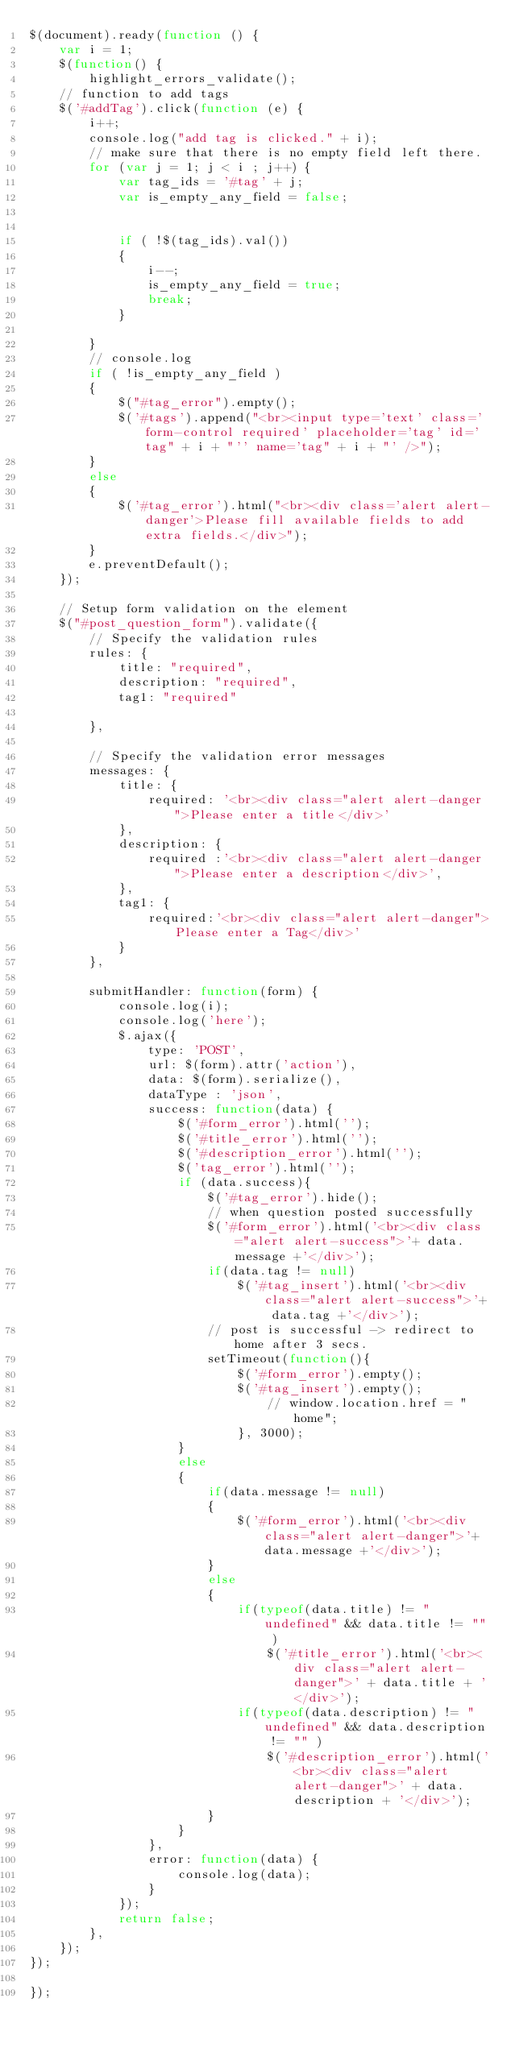<code> <loc_0><loc_0><loc_500><loc_500><_JavaScript_>$(document).ready(function () {
    var i = 1;
    $(function() {
        highlight_errors_validate();
    // function to add tags
    $('#addTag').click(function (e) {
        i++;
        console.log("add tag is clicked." + i);
        // make sure that there is no empty field left there.
        for (var j = 1; j < i ; j++) {
            var tag_ids = '#tag' + j;
            var is_empty_any_field = false;


            if ( !$(tag_ids).val())
            {
                i--;
                is_empty_any_field = true;
                break;
            }

        }
        // console.log
        if ( !is_empty_any_field )
        {
            $("#tag_error").empty();
            $('#tags').append("<br><input type='text' class='form-control required' placeholder='tag' id='tag" + i + "'' name='tag" + i + "' />");
        }
        else
        {
            $('#tag_error').html("<br><div class='alert alert-danger'>Please fill available fields to add extra fields.</div>");
        }
        e.preventDefault();  
    });

    // Setup form validation on the element
    $("#post_question_form").validate({
        // Specify the validation rules
        rules: {
            title: "required",
            description: "required",
            tag1: "required"
            
        },
        
        // Specify the validation error messages
        messages: {
            title: {
                required: '<br><div class="alert alert-danger">Please enter a title</div>'
            },
            description: {
                required :'<br><div class="alert alert-danger">Please enter a description</div>',
            },
            tag1: {
                required:'<br><div class="alert alert-danger">Please enter a Tag</div>'
            }
        },
        
        submitHandler: function(form) {
            console.log(i);
            console.log('here');
            $.ajax({  
                type: 'POST',
                url: $(form).attr('action'),
                data: $(form).serialize(),
                dataType : 'json',
                success: function(data) {
                    $('#form_error').html('');
                    $('#title_error').html('');
                    $('#description_error').html('');
                    $('tag_error').html('');
                    if (data.success){
                        $('#tag_error').hide();
                        // when question posted successfully
                        $('#form_error').html('<br><div class="alert alert-success">'+ data.message +'</div>');
                        if(data.tag != null)
                            $('#tag_insert').html('<br><div class="alert alert-success">'+ data.tag +'</div>');
                        // post is successful -> redirect to home after 3 secs.
                        setTimeout(function(){
                            $('#form_error').empty();
                            $('#tag_insert').empty();
                                // window.location.href = "home";
                            }, 3000);
                    }
                    else
                    {
                        if(data.message != null)
                        {
                            $('#form_error').html('<br><div class="alert alert-danger">'+ data.message +'</div>');
                        }
                        else
                        {
                            if(typeof(data.title) != "undefined" && data.title != "" )
                                $('#title_error').html('<br><div class="alert alert-danger">' + data.title + '</div>');
                            if(typeof(data.description) != "undefined" && data.description != "" )
                                $('#description_error').html('<br><div class="alert alert-danger">' + data.description + '</div>');
                        }
                    }
                },
                error: function(data) {
                    console.log(data);
                }
            });
            return false;
        },
    });
});

});</code> 